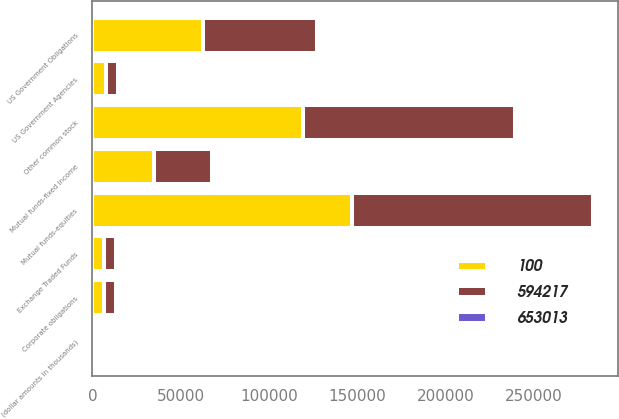Convert chart to OTSL. <chart><loc_0><loc_0><loc_500><loc_500><stacked_bar_chart><ecel><fcel>(dollar amounts in thousands)<fcel>Corporate obligations<fcel>US Government Obligations<fcel>Mutual funds-fixed income<fcel>US Government Agencies<fcel>Mutual funds-equities<fcel>Other common stock<fcel>Exchange Traded Funds<nl><fcel>594217<fcel>2015<fcel>6685<fcel>64456<fcel>32874<fcel>6979<fcel>136026<fcel>120046<fcel>6530<nl><fcel>653013<fcel>2015<fcel>34<fcel>11<fcel>6<fcel>1<fcel>23<fcel>20<fcel>1<nl><fcel>100<fcel>2014<fcel>6685<fcel>62627<fcel>34761<fcel>7445<fcel>147191<fcel>118970<fcel>6840<nl></chart> 